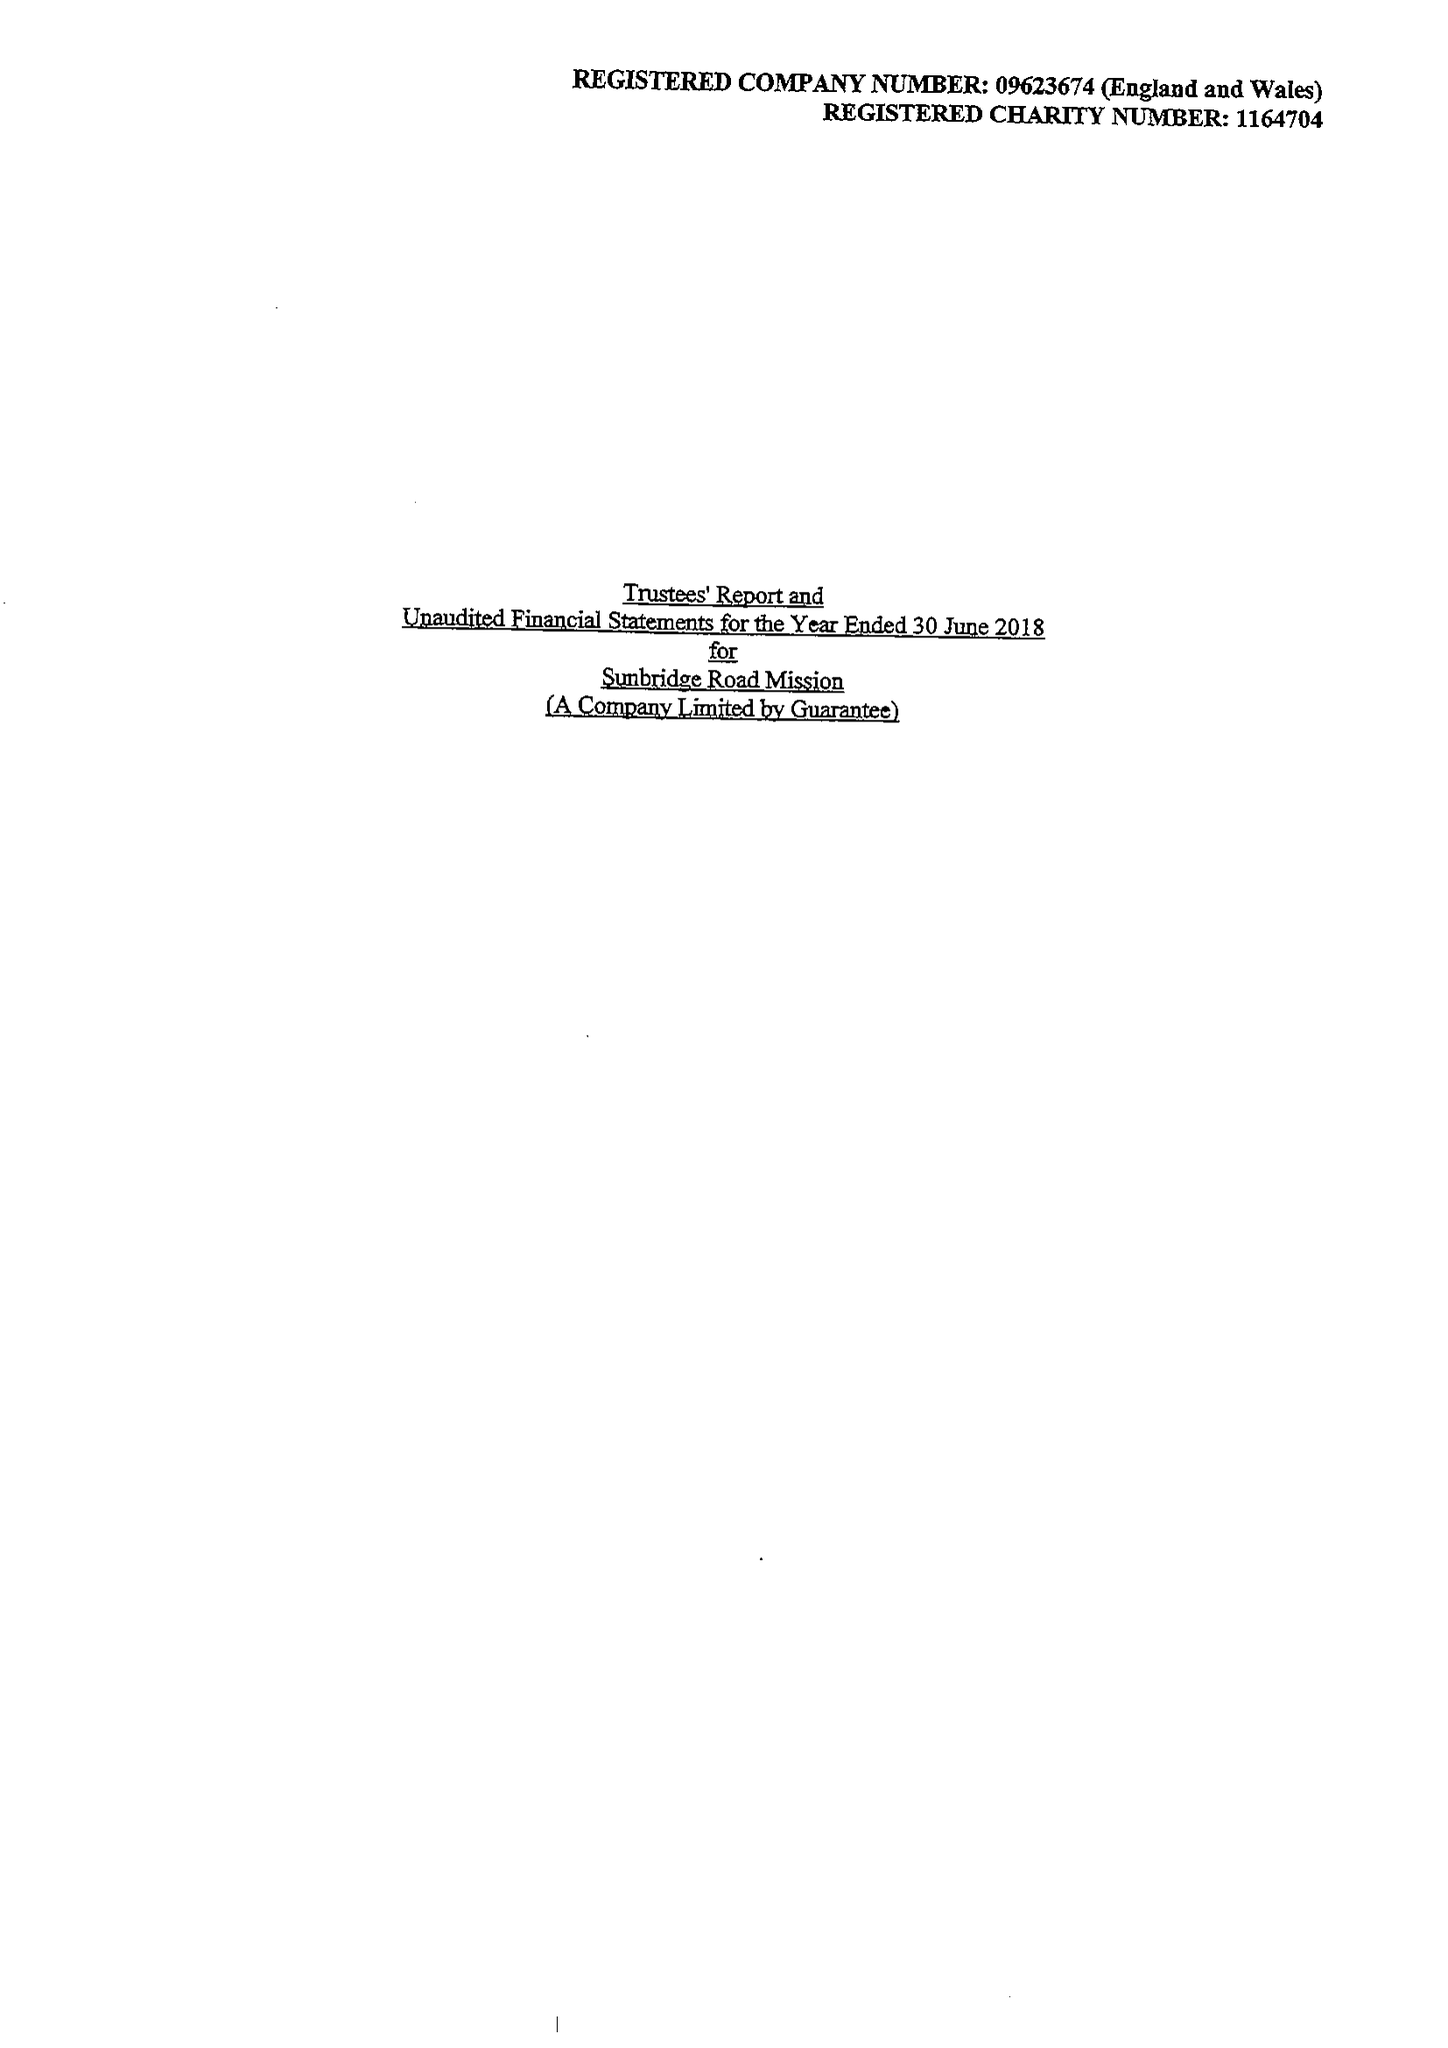What is the value for the charity_number?
Answer the question using a single word or phrase. 1164704 